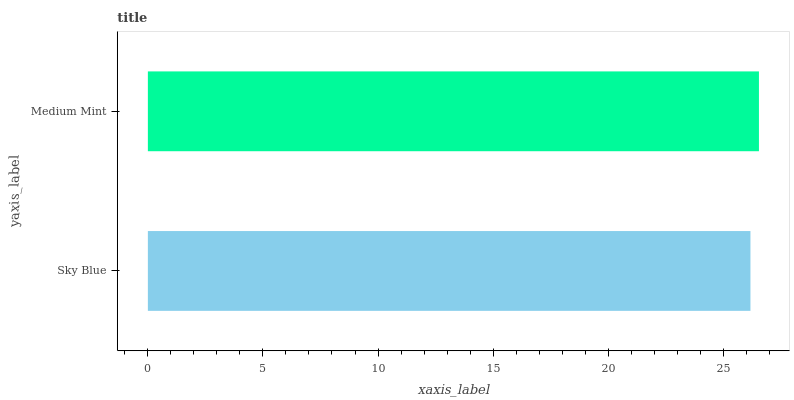Is Sky Blue the minimum?
Answer yes or no. Yes. Is Medium Mint the maximum?
Answer yes or no. Yes. Is Medium Mint the minimum?
Answer yes or no. No. Is Medium Mint greater than Sky Blue?
Answer yes or no. Yes. Is Sky Blue less than Medium Mint?
Answer yes or no. Yes. Is Sky Blue greater than Medium Mint?
Answer yes or no. No. Is Medium Mint less than Sky Blue?
Answer yes or no. No. Is Medium Mint the high median?
Answer yes or no. Yes. Is Sky Blue the low median?
Answer yes or no. Yes. Is Sky Blue the high median?
Answer yes or no. No. Is Medium Mint the low median?
Answer yes or no. No. 